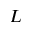<formula> <loc_0><loc_0><loc_500><loc_500>L</formula> 